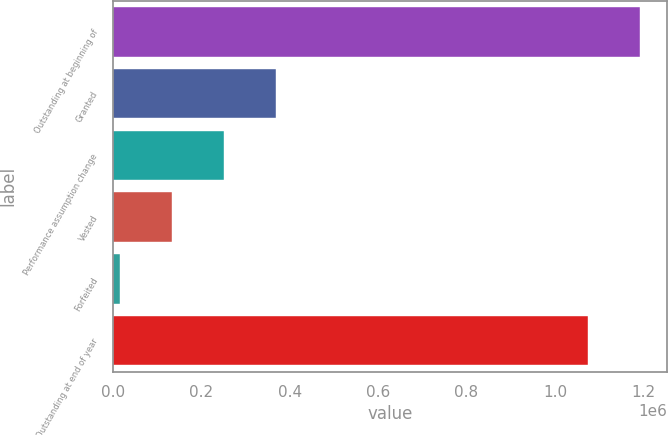Convert chart to OTSL. <chart><loc_0><loc_0><loc_500><loc_500><bar_chart><fcel>Outstanding at beginning of<fcel>Granted<fcel>Performance assumption change<fcel>Vested<fcel>Forfeited<fcel>Outstanding at end of year<nl><fcel>1.19335e+06<fcel>368159<fcel>250558<fcel>132957<fcel>15356<fcel>1.07575e+06<nl></chart> 